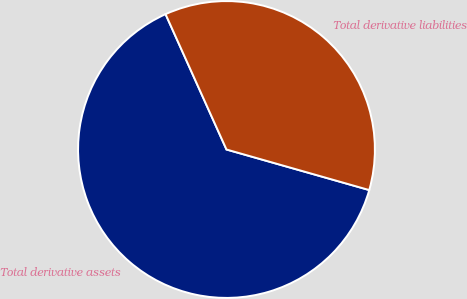Convert chart to OTSL. <chart><loc_0><loc_0><loc_500><loc_500><pie_chart><fcel>Total derivative assets<fcel>Total derivative liabilities<nl><fcel>63.86%<fcel>36.14%<nl></chart> 